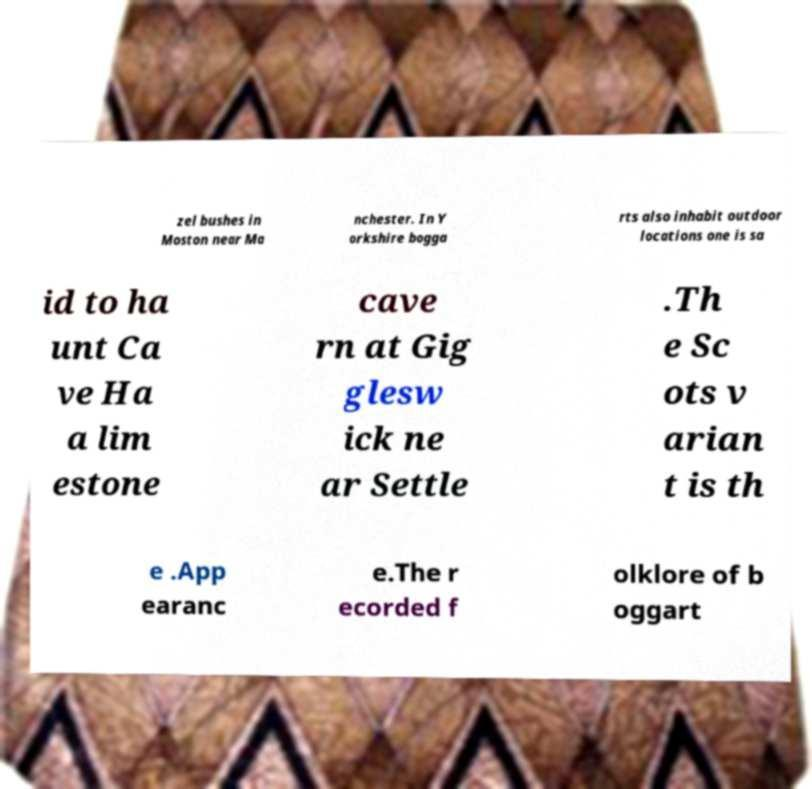Can you accurately transcribe the text from the provided image for me? zel bushes in Moston near Ma nchester. In Y orkshire bogga rts also inhabit outdoor locations one is sa id to ha unt Ca ve Ha a lim estone cave rn at Gig glesw ick ne ar Settle .Th e Sc ots v arian t is th e .App earanc e.The r ecorded f olklore of b oggart 